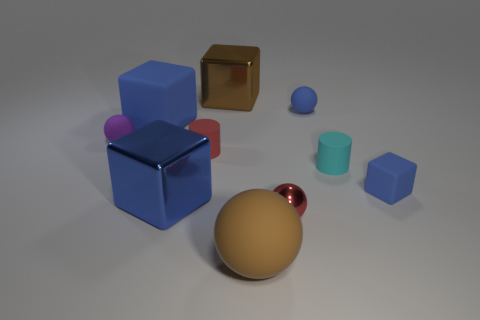Subtract all small spheres. How many spheres are left? 1 Subtract all blocks. How many objects are left? 6 Subtract all blue blocks. How many blocks are left? 1 Subtract 0 cyan balls. How many objects are left? 10 Subtract 3 cubes. How many cubes are left? 1 Subtract all gray blocks. Subtract all green balls. How many blocks are left? 4 Subtract all brown balls. How many blue cubes are left? 3 Subtract all red cylinders. Subtract all small rubber balls. How many objects are left? 7 Add 2 matte cylinders. How many matte cylinders are left? 4 Add 1 tiny purple cylinders. How many tiny purple cylinders exist? 1 